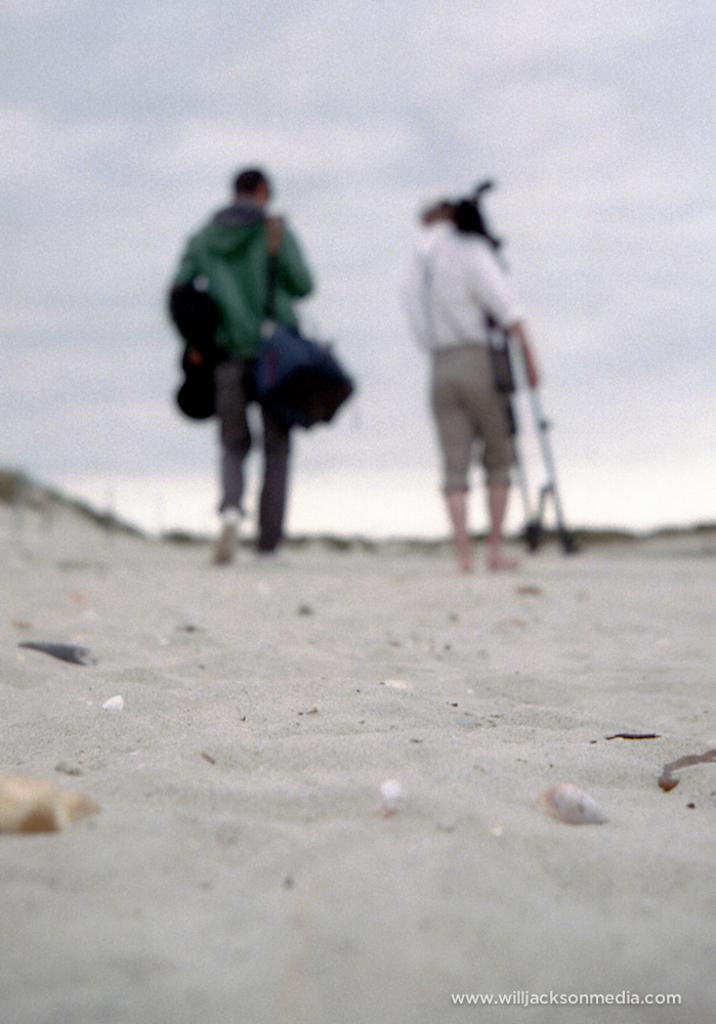Please provide a concise description of this image. In the center of the image there are two people walking on sand holding some objects. At the top of the image there is sky and clouds. 